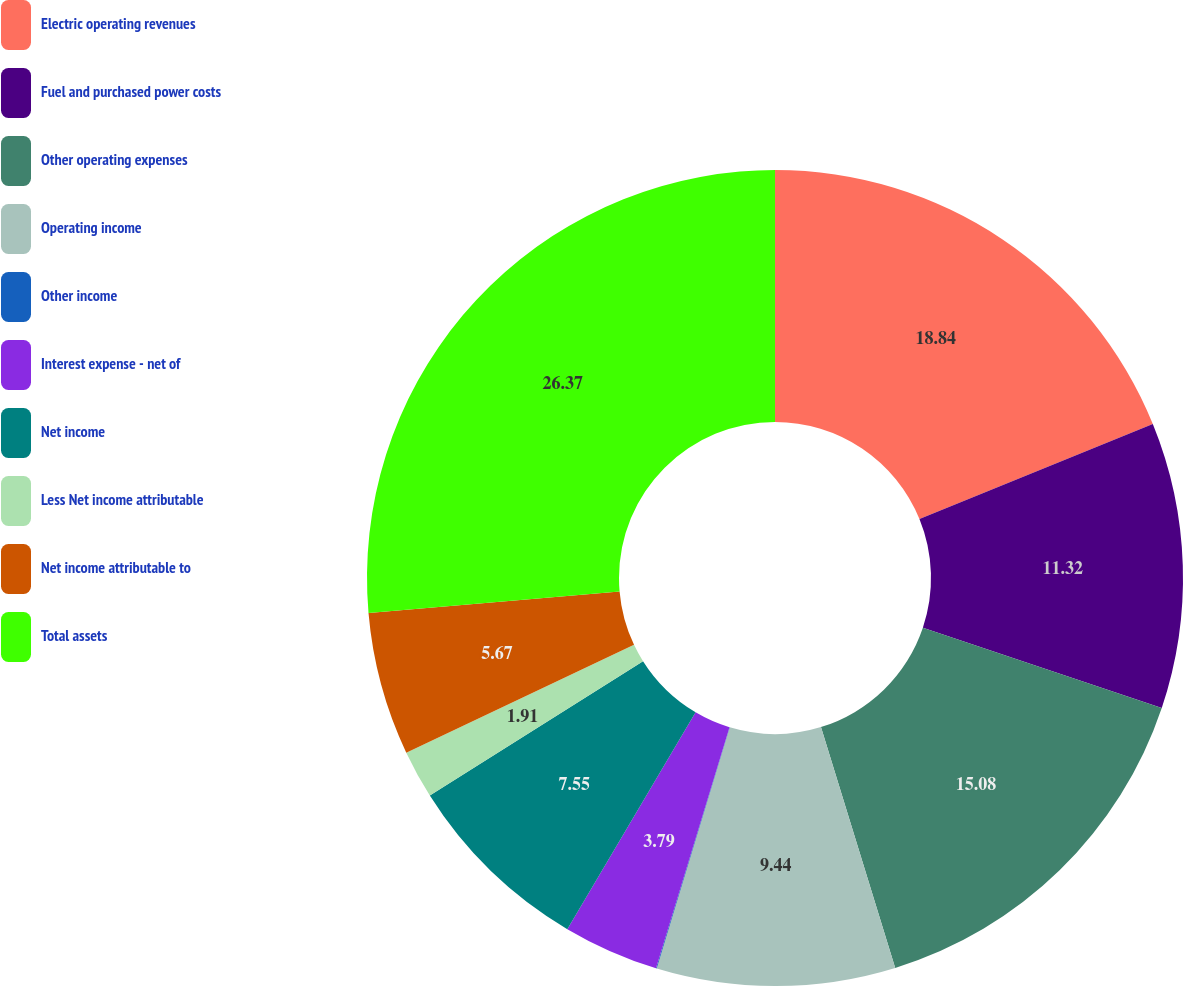Convert chart to OTSL. <chart><loc_0><loc_0><loc_500><loc_500><pie_chart><fcel>Electric operating revenues<fcel>Fuel and purchased power costs<fcel>Other operating expenses<fcel>Operating income<fcel>Other income<fcel>Interest expense - net of<fcel>Net income<fcel>Less Net income attributable<fcel>Net income attributable to<fcel>Total assets<nl><fcel>18.84%<fcel>11.32%<fcel>15.08%<fcel>9.44%<fcel>0.03%<fcel>3.79%<fcel>7.55%<fcel>1.91%<fcel>5.67%<fcel>26.37%<nl></chart> 